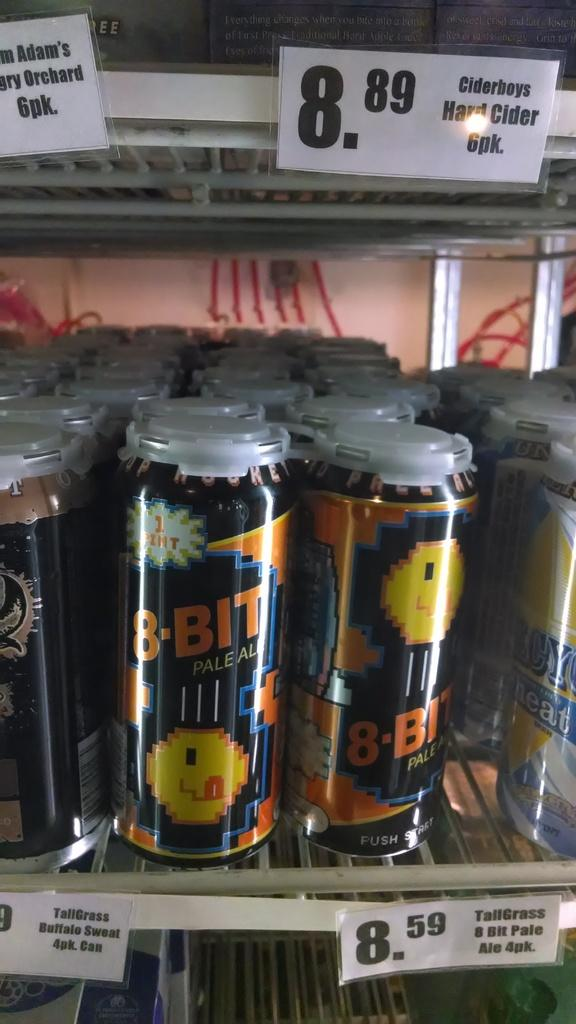<image>
Write a terse but informative summary of the picture. A fridge full of beer that says 8-BIT Pale Ale in a store and has a price tag that says 8.59. 